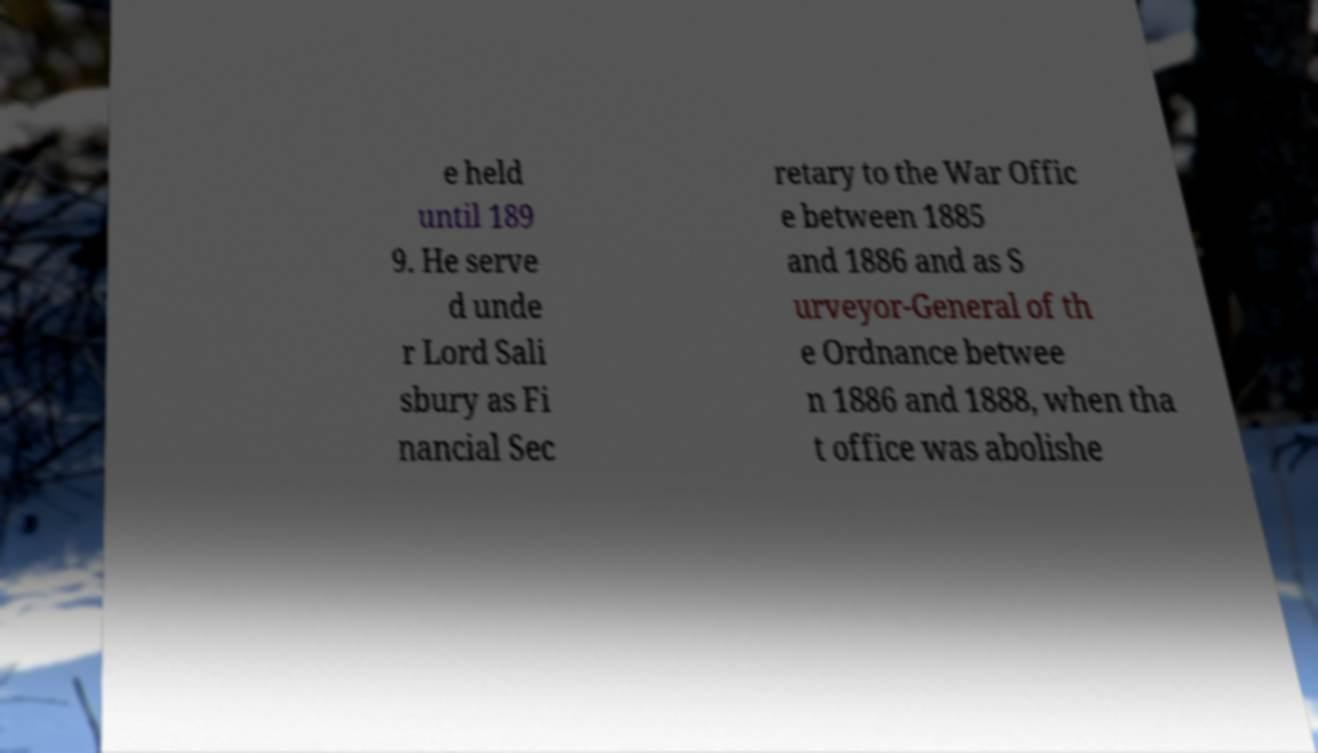Please read and relay the text visible in this image. What does it say? e held until 189 9. He serve d unde r Lord Sali sbury as Fi nancial Sec retary to the War Offic e between 1885 and 1886 and as S urveyor-General of th e Ordnance betwee n 1886 and 1888, when tha t office was abolishe 